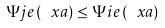<formula> <loc_0><loc_0><loc_500><loc_500>\Psi j e \left ( \ x a \right ) \leq \Psi i e \left ( \ x a \right )</formula> 